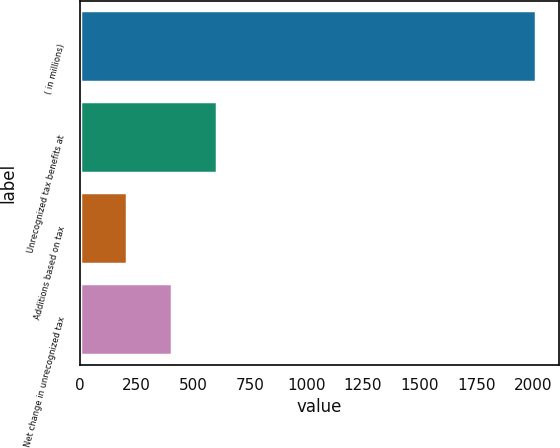Convert chart to OTSL. <chart><loc_0><loc_0><loc_500><loc_500><bar_chart><fcel>( in millions)<fcel>Unrecognized tax benefits at<fcel>Additions based on tax<fcel>Net change in unrecognized tax<nl><fcel>2012<fcel>607.8<fcel>206.6<fcel>407.2<nl></chart> 